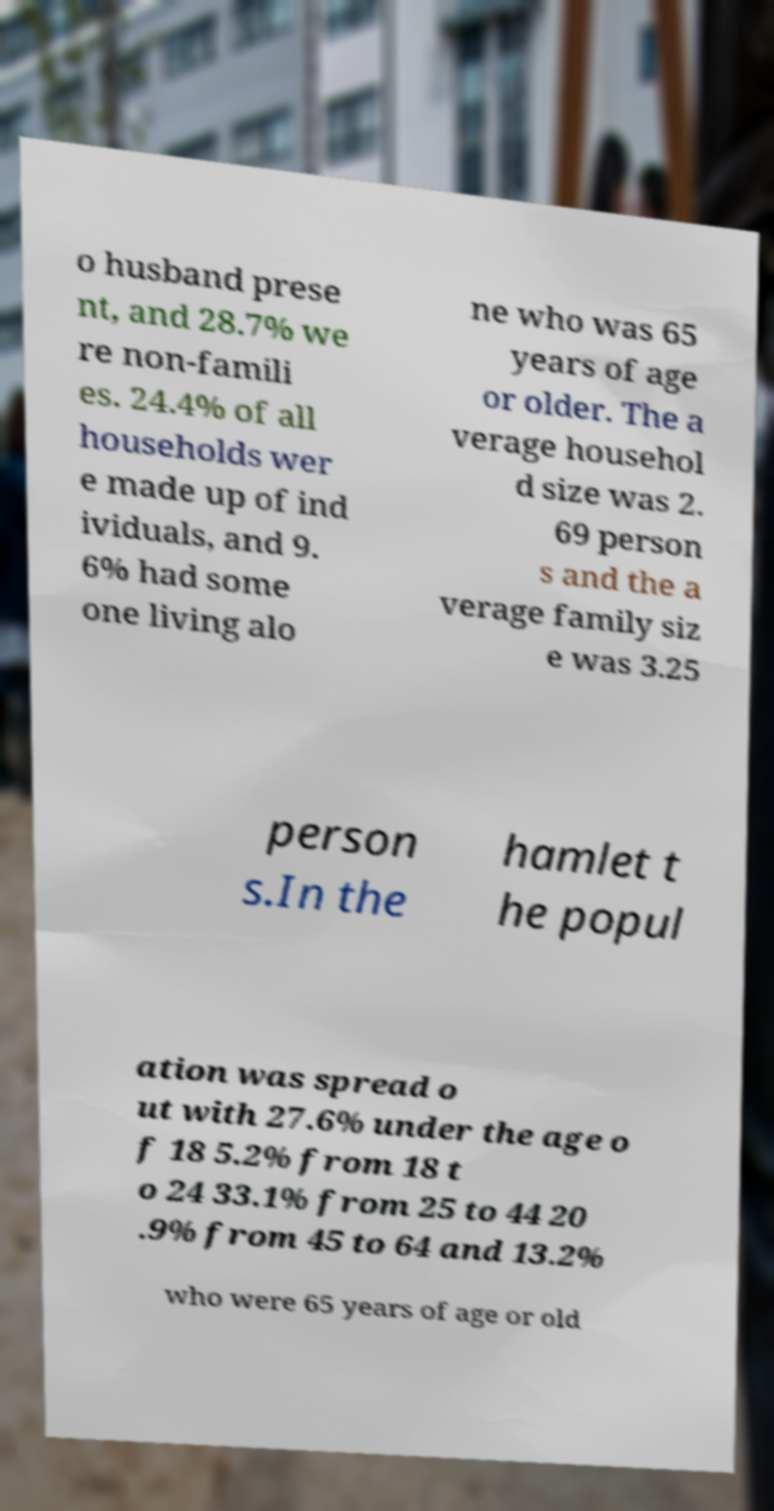What messages or text are displayed in this image? I need them in a readable, typed format. o husband prese nt, and 28.7% we re non-famili es. 24.4% of all households wer e made up of ind ividuals, and 9. 6% had some one living alo ne who was 65 years of age or older. The a verage househol d size was 2. 69 person s and the a verage family siz e was 3.25 person s.In the hamlet t he popul ation was spread o ut with 27.6% under the age o f 18 5.2% from 18 t o 24 33.1% from 25 to 44 20 .9% from 45 to 64 and 13.2% who were 65 years of age or old 